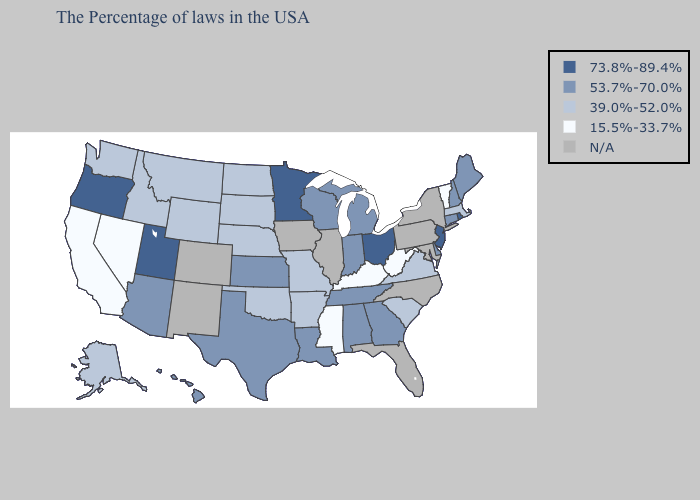Is the legend a continuous bar?
Be succinct. No. Does Oregon have the lowest value in the USA?
Quick response, please. No. What is the value of Washington?
Answer briefly. 39.0%-52.0%. Which states have the lowest value in the USA?
Short answer required. Vermont, West Virginia, Kentucky, Mississippi, Nevada, California. What is the highest value in the USA?
Quick response, please. 73.8%-89.4%. Does the map have missing data?
Give a very brief answer. Yes. What is the value of Illinois?
Write a very short answer. N/A. What is the value of Kansas?
Short answer required. 53.7%-70.0%. What is the value of Oklahoma?
Answer briefly. 39.0%-52.0%. Name the states that have a value in the range 53.7%-70.0%?
Concise answer only. Maine, New Hampshire, Connecticut, Delaware, Georgia, Michigan, Indiana, Alabama, Tennessee, Wisconsin, Louisiana, Kansas, Texas, Arizona, Hawaii. Does Idaho have the highest value in the West?
Write a very short answer. No. Name the states that have a value in the range 39.0%-52.0%?
Be succinct. Massachusetts, Virginia, South Carolina, Missouri, Arkansas, Nebraska, Oklahoma, South Dakota, North Dakota, Wyoming, Montana, Idaho, Washington, Alaska. What is the highest value in the USA?
Quick response, please. 73.8%-89.4%. What is the value of Louisiana?
Be succinct. 53.7%-70.0%. 